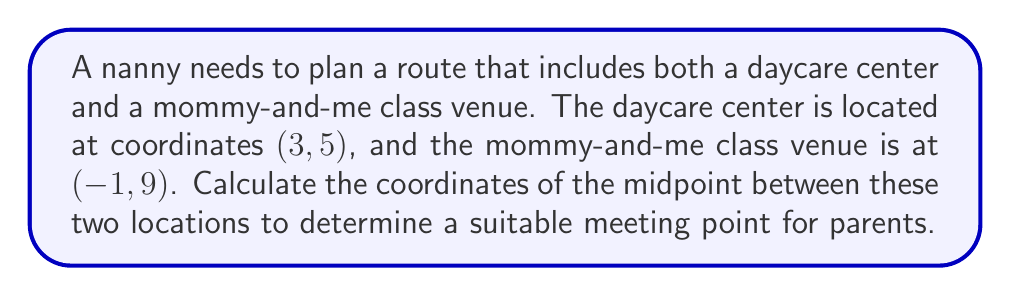Could you help me with this problem? To find the midpoint between two points, we use the midpoint formula:

$$ \text{Midpoint} = \left(\frac{x_1 + x_2}{2}, \frac{y_1 + y_2}{2}\right) $$

Where $(x_1, y_1)$ are the coordinates of the first point and $(x_2, y_2)$ are the coordinates of the second point.

In this case:
- Daycare center: $(x_1, y_1) = (3, 5)$
- Mommy-and-me class venue: $(x_2, y_2) = (-1, 9)$

Let's substitute these values into the midpoint formula:

$$ \text{Midpoint} = \left(\frac{3 + (-1)}{2}, \frac{5 + 9}{2}\right) $$

Simplifying:

$$ \text{Midpoint} = \left(\frac{2}{2}, \frac{14}{2}\right) $$

$$ \text{Midpoint} = (1, 7) $$

Therefore, the midpoint between the daycare center and the mommy-and-me class venue is at coordinates (1, 7).

[asy]
unitsize(1cm);
draw((-2,-1)--(4,10), gray);
dot((3,5), red);
dot((-1,9), blue);
dot((1,7), green);
label("Daycare (3,5)", (3,5), E, red);
label("Mommy-and-me (−1,9)", (-1,9), W, blue);
label("Midpoint (1,7)", (1,7), S, green);
[/asy]
Answer: The midpoint is (1, 7). 